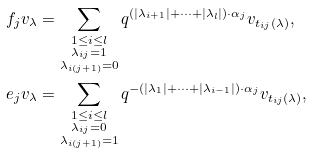<formula> <loc_0><loc_0><loc_500><loc_500>f _ { j } v _ { \lambda } & = \sum _ { \substack { 1 \leq i \leq l \\ \lambda _ { i j } = 1 \\ \lambda _ { i ( j + 1 ) } = 0 } } q ^ { ( | \lambda _ { i + 1 } | + \cdots + | \lambda _ { l } | ) \cdot \alpha _ { j } } v _ { t _ { i j } ( \lambda ) } , \\ e _ { j } v _ { \lambda } & = \sum _ { \substack { 1 \leq i \leq l \\ \lambda _ { i j } = 0 \\ \lambda _ { i ( j + 1 ) } = 1 } } q ^ { - ( | \lambda _ { 1 } | + \cdots + | \lambda _ { i - 1 } | ) \cdot \alpha _ { j } } v _ { t _ { i j } ( \lambda ) } ,</formula> 